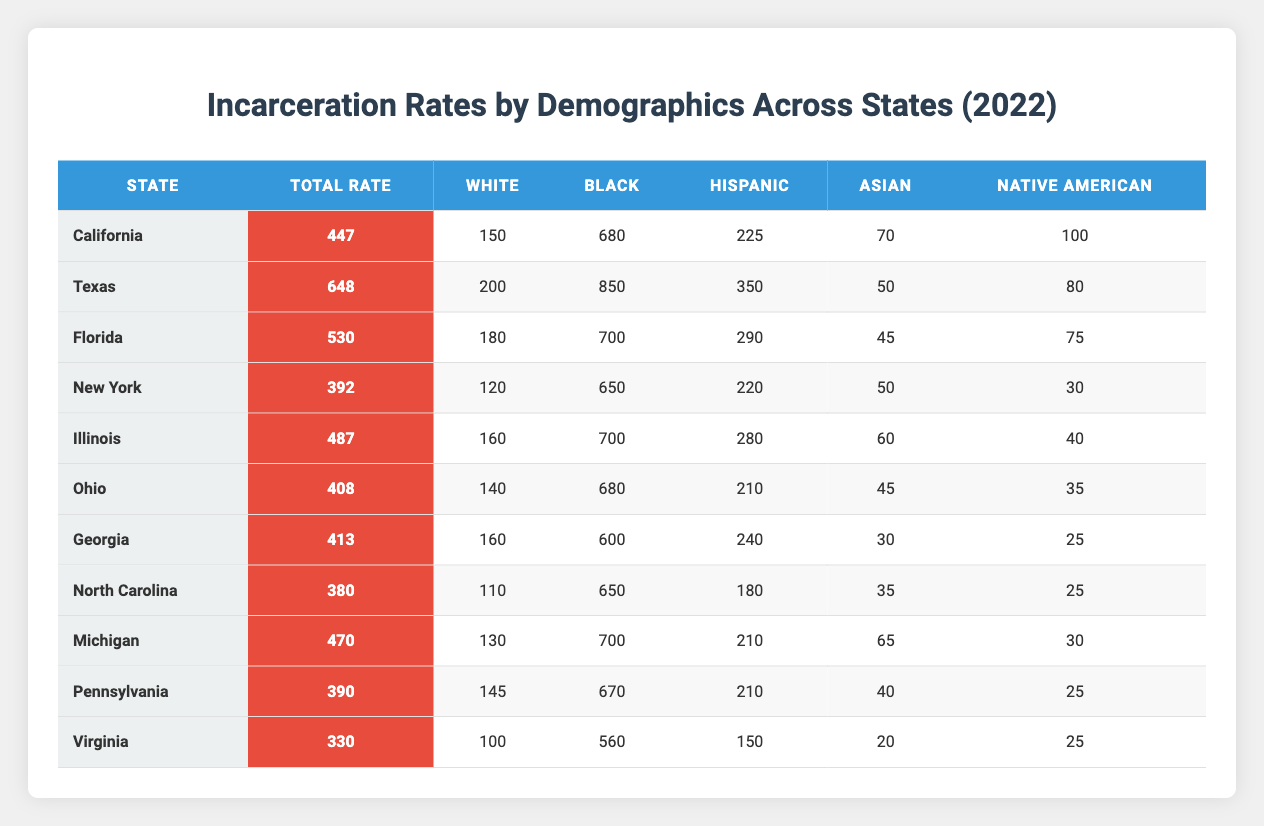What is the total incarceration rate for Texas? The total incarceration rate for Texas, as listed in the table, is 648.
Answer: 648 Which state has the highest incarceration rate for Black individuals? By examining the table, Texas has the highest incarceration rate for Black individuals at 850.
Answer: 850 What is the average total incarceration rate across all the states? The total incarceration rates across all states are summed: (447 + 648 + 530 + 392 + 487 + 408 + 413 + 380 + 470 + 390 + 330) = 4715. There are 11 states, so the average total incarceration rate is 4715/11 = 429.55, which can be rounded to 430.
Answer: 430 Is the incarceration rate for Hispanics in Florida higher than the rate for Whites in New York? The incarceration rate for Hispanics in Florida is 290, while the rate for Whites in New York is 120. 290 is greater than 120, so the answer is yes.
Answer: Yes What is the difference between the total incarceration rate of California and Virginia? The total incarceration rate in California is 447 and in Virginia, it is 330. The difference is calculated as 447 - 330 = 117.
Answer: 117 How many states have a total incarceration rate above 400? By reviewing the table, the states with total incarceration rates above 400 are California, Texas, Florida, Illinois, Ohio, Georgia, Michigan, and Pennsylvania, totaling 8 states.
Answer: 8 Is the total incarceration rate for Michigan higher than that for Ohio? The total incarceration rate for Michigan is 470, while for Ohio it is 408. Since 470 is greater than 408, the answer is yes.
Answer: Yes What is the least total incarceration rate among the states listed? The least total incarceration rate in the table can be found in Virginia, where the rate is 330.
Answer: 330 Which demographic has the highest incarceration rate in California? According to the table data, the highest incarceration rate demographic in California is Black individuals at 680.
Answer: 680 What is the total incarceration rate for Hispanic individuals across all listed states? The total for Hispanic individuals is calculated by summing their rates: (225 + 350 + 290 + 220 + 280 + 210 + 240 + 180 + 210 + 150) = 2,325.
Answer: 2325 